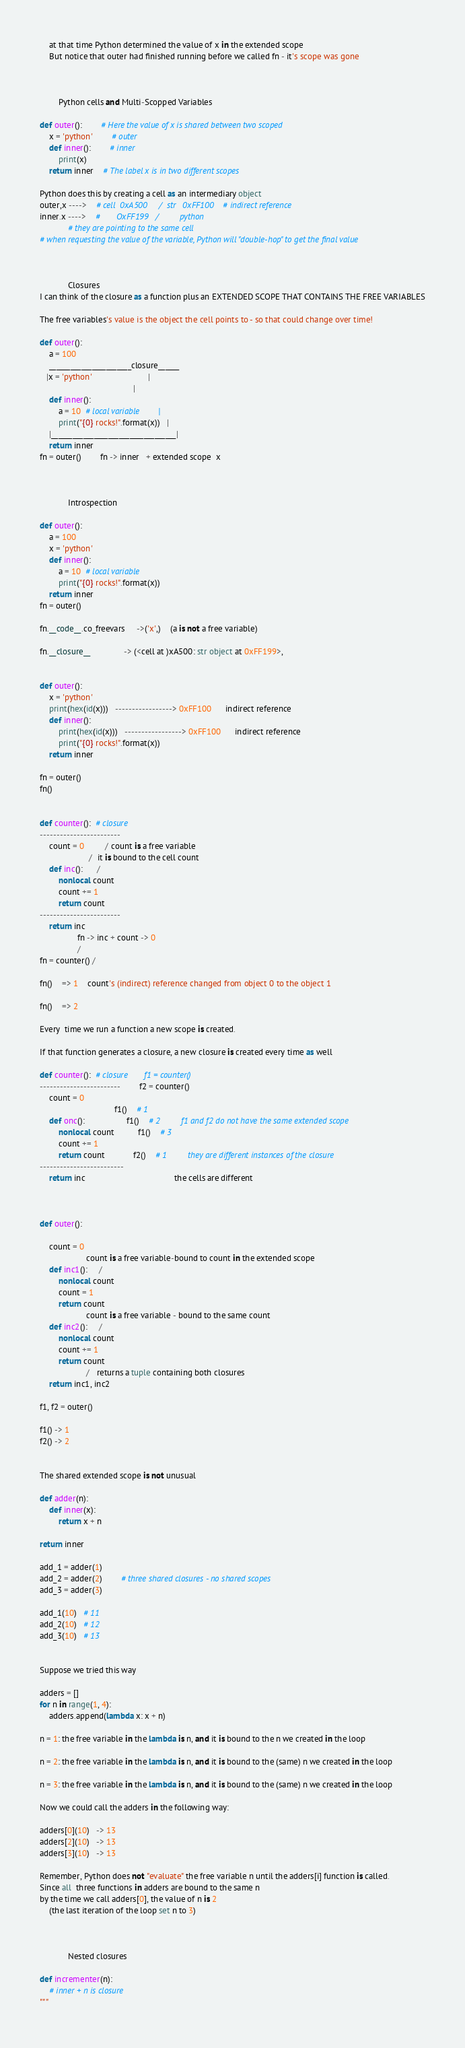Convert code to text. <code><loc_0><loc_0><loc_500><loc_500><_Python_>    at that time Python determined the value of x in the extended scope
    But notice that outer had finished running before we called fn - it's scope was gone



        Python cells and Multi-Scopped Variables

def outer():        # Here the value of x is shared between two scoped
    x = 'python'        # outer
    def inner():        # inner
        print(x)
    return inner    # The label x is in two different scopes

Python does this by creating a cell as an intermediary object
outer,x ---->    # cell  0xA500     /  str   0xFF100    # indirect reference
inner.x ---->    #       OxFF199   /         python
            # they are pointing to the same cell
# when requesting the value of the variable, Python will "double-hop" to get the final value



            Closures
I can think of the closure as a function plus an EXTENDED SCOPE THAT CONTAINS THE FREE VARIABLES

The free variables's value is the object the cell points to - so that could change over time!

def outer():
    a = 100
    _______________________closure______
   |x = 'python'                        |
                                        |
    def inner():
        a = 10  # local variable        |
        print("{0} rocks!".format(x))   |
    |___________________________________|
    return inner
fn = outer()        fn -> inner   + extended scope  x



            Introspection

def outer():
    a = 100
    x = 'python'
    def inner():
        a = 10  # local variable
        print("{0} rocks!".format(x))
    return inner
fn = outer()

fn.__code__.co_freevars     ->('x',)    (a is not a free variable)

fn.__closure__              -> (<cell at )xA500: str object at 0xFF199>,


def outer():
    x = 'python'
    print(hex(id(x)))   -----------------> 0xFF100      indirect reference
    def inner():
        print(hex(id(x)))   -----------------> 0xFF100      indirect reference
        print("{0} rocks!".format(x))
    return inner

fn = outer()
fn()


def counter():  # closure
------------------------
    count = 0         / count is a free variable
                     /  it is bound to the cell count
    def inc():      /
        nonlocal count
        count += 1
        return count
------------------------
    return inc
                fn -> inc + count -> 0
                /
fn = counter() /

fn()    => 1    count's (indirect) reference changed from object 0 to the object 1

fn()    => 2

Every  time we run a function a new scope is created.

If that function generates a closure, a new closure is created every time as well

def counter():  # closure       f1 = counter()
------------------------        f2 = counter()
    count = 0
                                f1()    # 1
    def onc():                  f1()    # 2         f1 and f2 do not have the same extended scope
        nonlocal count          f1()    # 3
        count += 1
        return count            f2()    # 1         they are different instances of the closure
-------------------------
    return inc                                      the cells are different



def outer():

    count = 0
                    count is a free variable-bound to count in the extended scope
    def inc1():     /
        nonlocal count
        count = 1
        return count
                    count is a free variable - bound to the same count
    def inc2():     /
        nonlocal count
        count += 1
        return count
                    /   returns a tuple containing both closures
    return inc1, inc2

f1, f2 = outer()

f1() -> 1
f2() -> 2


The shared extended scope is not unusual

def adder(n):
    def inner(x):
        return x + n

return inner

add_1 = adder(1)
add_2 = adder(2)        # three shared closures - no shared scopes
add_3 = adder(3)

add_1(10)   # 11
add_2(10)   # 12
add_3(10)   # 13


Suppose we tried this way

adders = []
for n in range(1, 4):
    adders.append(lambda x: x + n)

n = 1: the free variable in the lambda is n, and it is bound to the n we created in the loop

n = 2: the free variable in the lambda is n, and it is bound to the (same) n we created in the loop

n = 3: the free variable in the lambda is n, and it is bound to the (same) n we created in the loop

Now we could call the adders in the following way:

adders[0](10)   -> 13
adders[2](10)   -> 13
adders[3](10)   -> 13

Remember, Python does not "evaluate" the free variable n until the adders[i] function is called.
Since all  three functions in adders are bound to the same n
by the time we call adders[0], the value of n is 2
    (the last iteration of the loop set n to 3)



            Nested closures

def incrementer(n):
    # inner + n is closure
"""</code> 